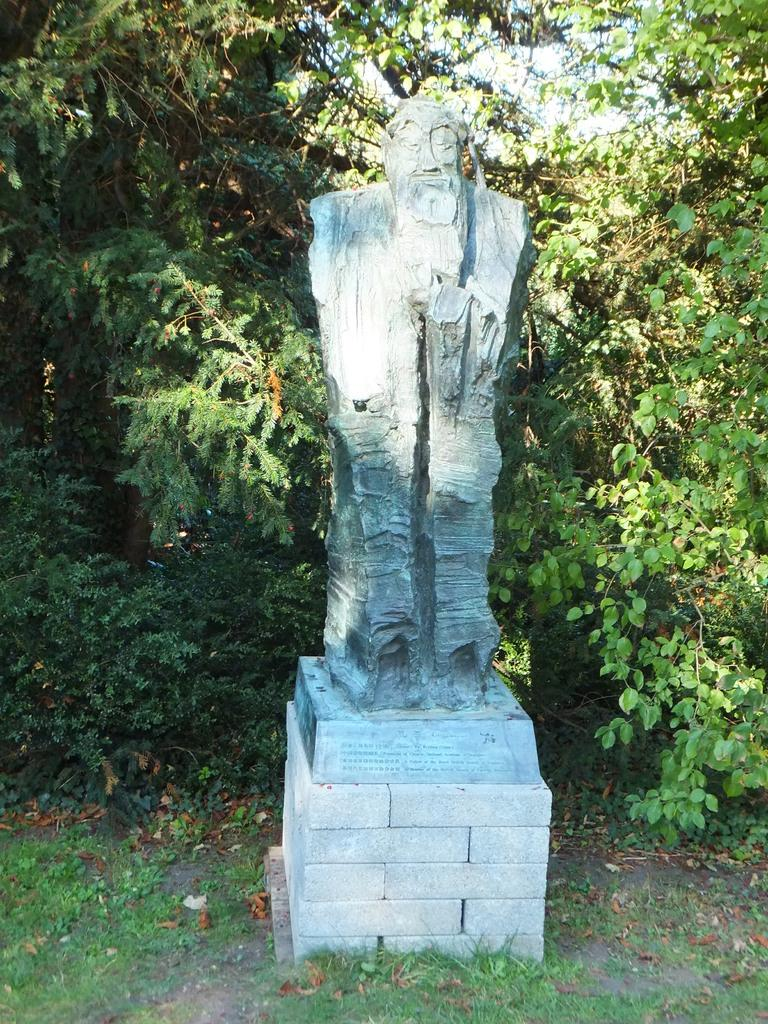What is the main subject of the image? There is a statue of a person in the image. Where is the statue located? The statue is on a brick wall. What type of vegetation can be seen in the image? There is a tree visible in the image. What is visible in the background of the image? The sky is visible in the image. What type of ground cover is present in the bottom left corner of the image? There is grass in the bottom left corner of the image. Reasoning: Let'g: Let's think step by step in order to produce the conversation. We start by identifying the main subject of the image, which is the statue of a person. Then, we describe the location of the statue, which is on a brick wall. Next, we mention the presence of a tree and the sky in the image, which provide context for the setting. Finally, we focus on the grass in the bottom left corner, which adds detail to the ground cover. Absurd Question/Answer: What type of pen is the statue holding in the image? There is no pen present in the image; the statue is not holding any object. 